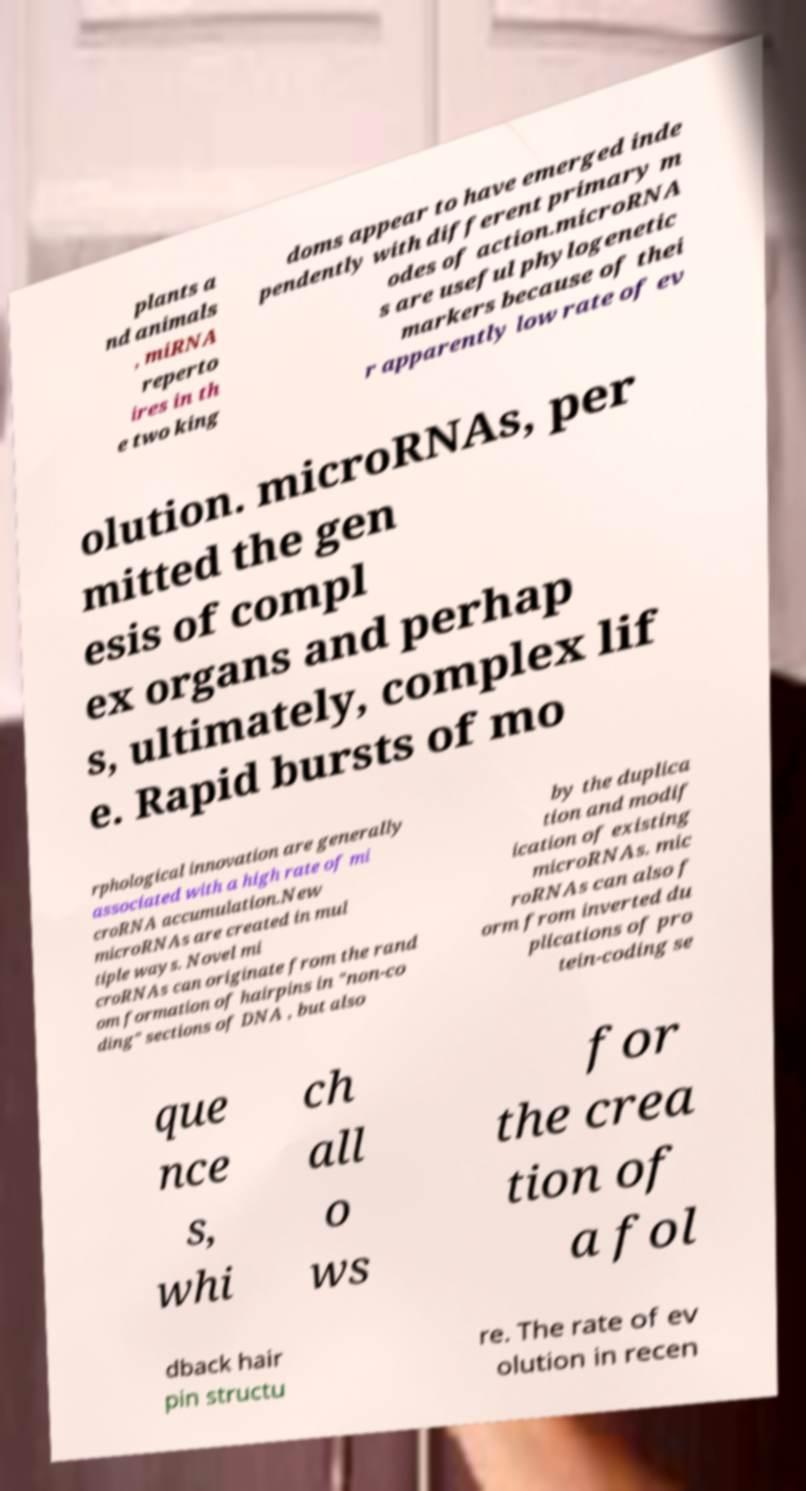Could you extract and type out the text from this image? plants a nd animals , miRNA reperto ires in th e two king doms appear to have emerged inde pendently with different primary m odes of action.microRNA s are useful phylogenetic markers because of thei r apparently low rate of ev olution. microRNAs, per mitted the gen esis of compl ex organs and perhap s, ultimately, complex lif e. Rapid bursts of mo rphological innovation are generally associated with a high rate of mi croRNA accumulation.New microRNAs are created in mul tiple ways. Novel mi croRNAs can originate from the rand om formation of hairpins in "non-co ding" sections of DNA , but also by the duplica tion and modif ication of existing microRNAs. mic roRNAs can also f orm from inverted du plications of pro tein-coding se que nce s, whi ch all o ws for the crea tion of a fol dback hair pin structu re. The rate of ev olution in recen 